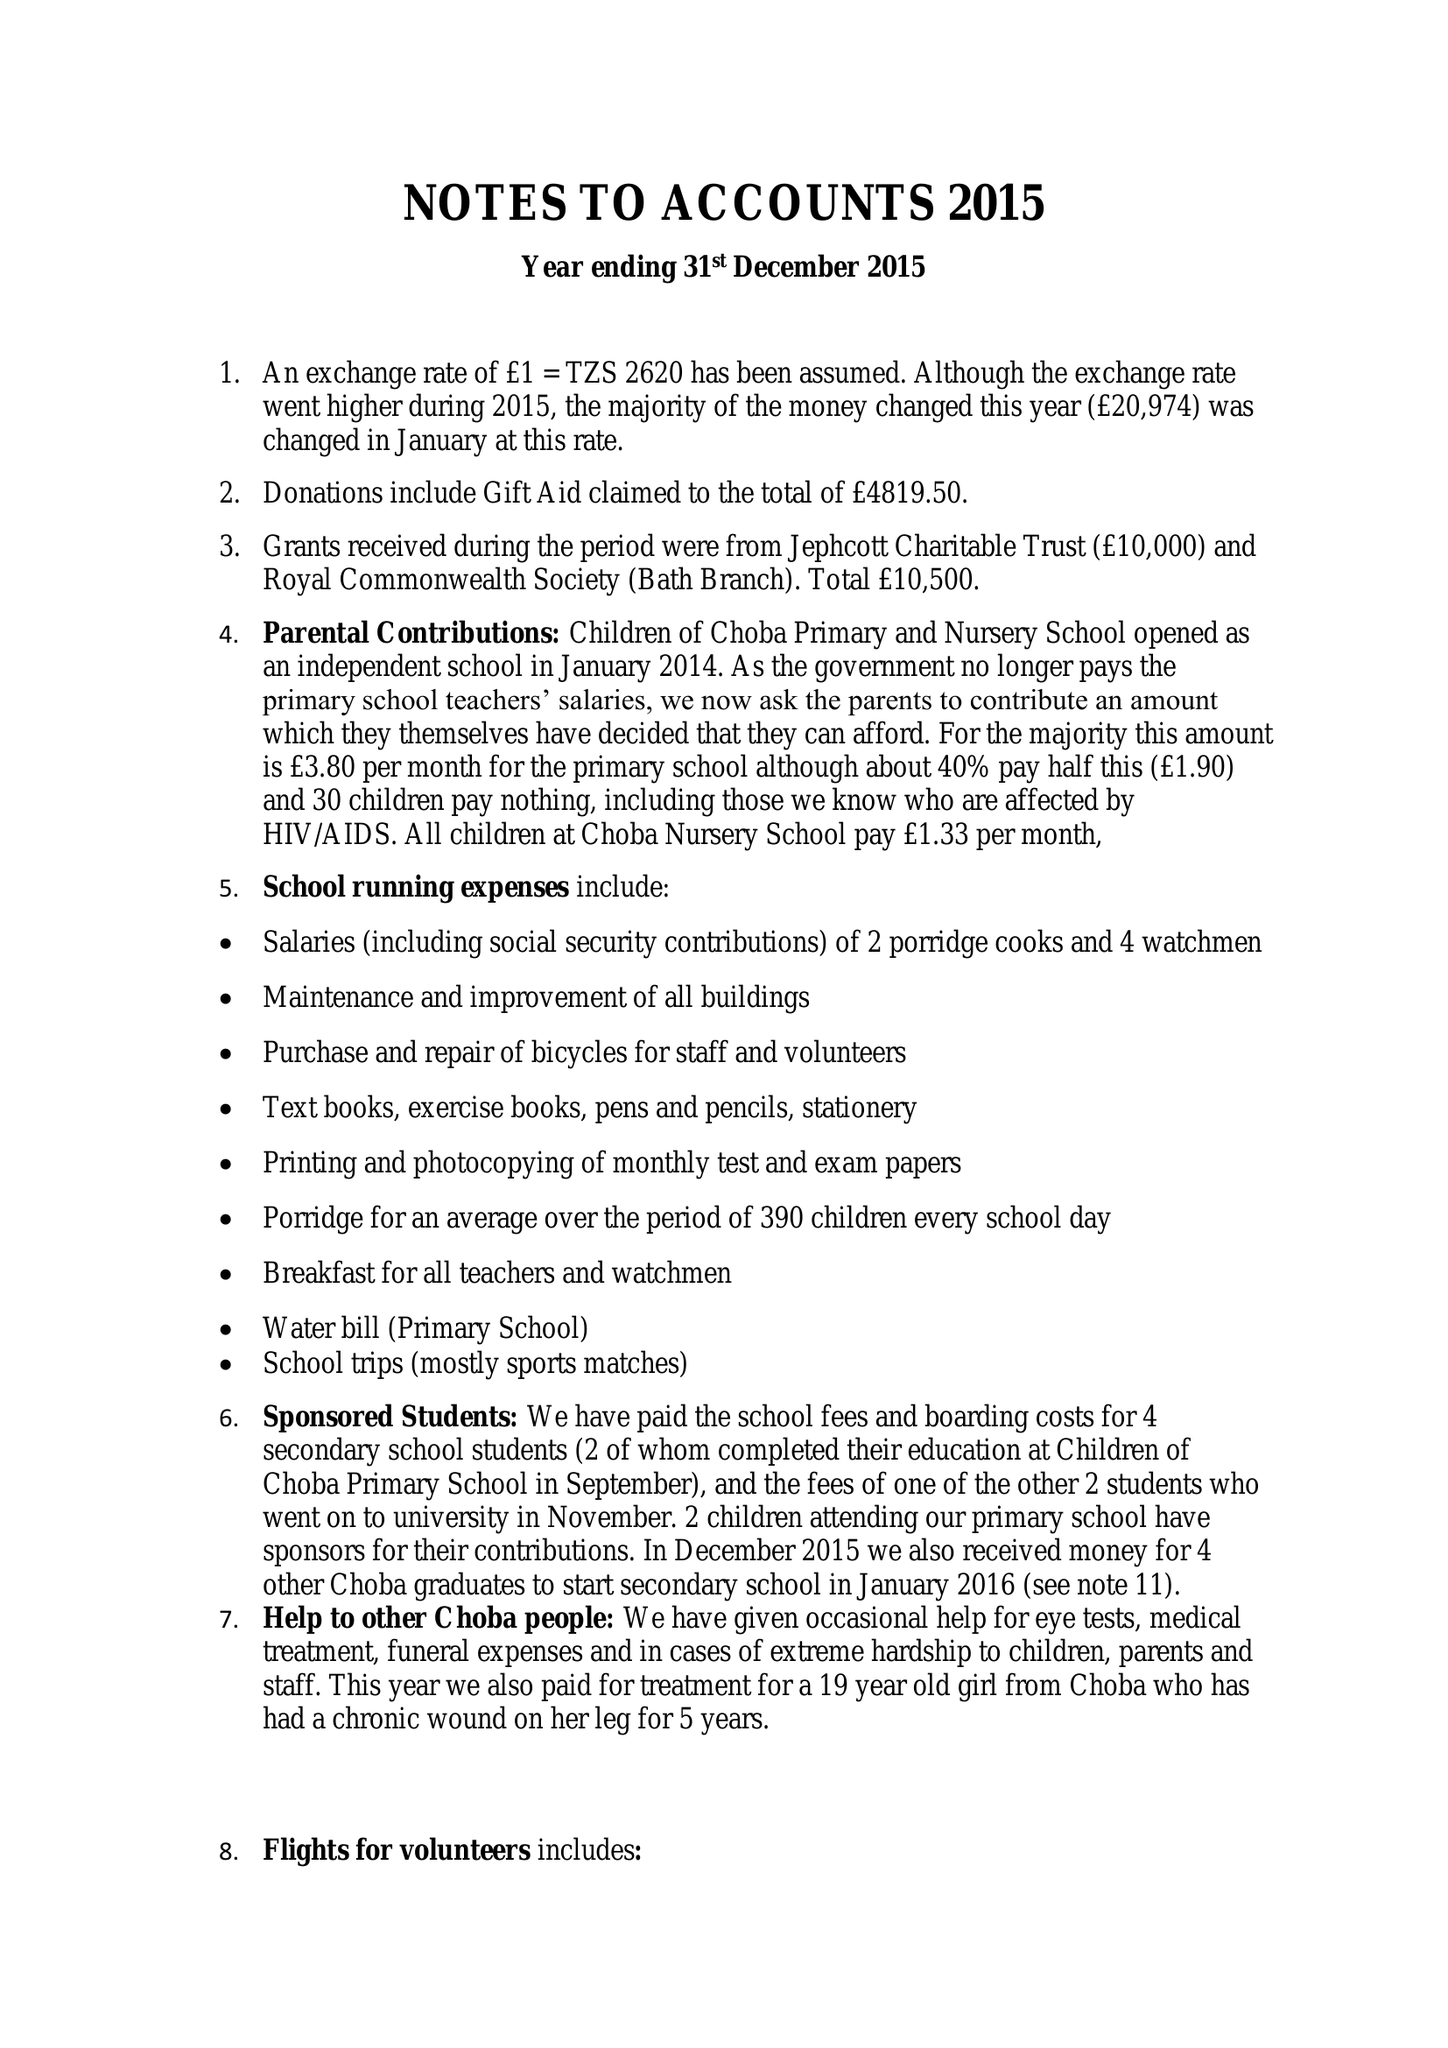What is the value for the spending_annually_in_british_pounds?
Answer the question using a single word or phrase. 54194.00 